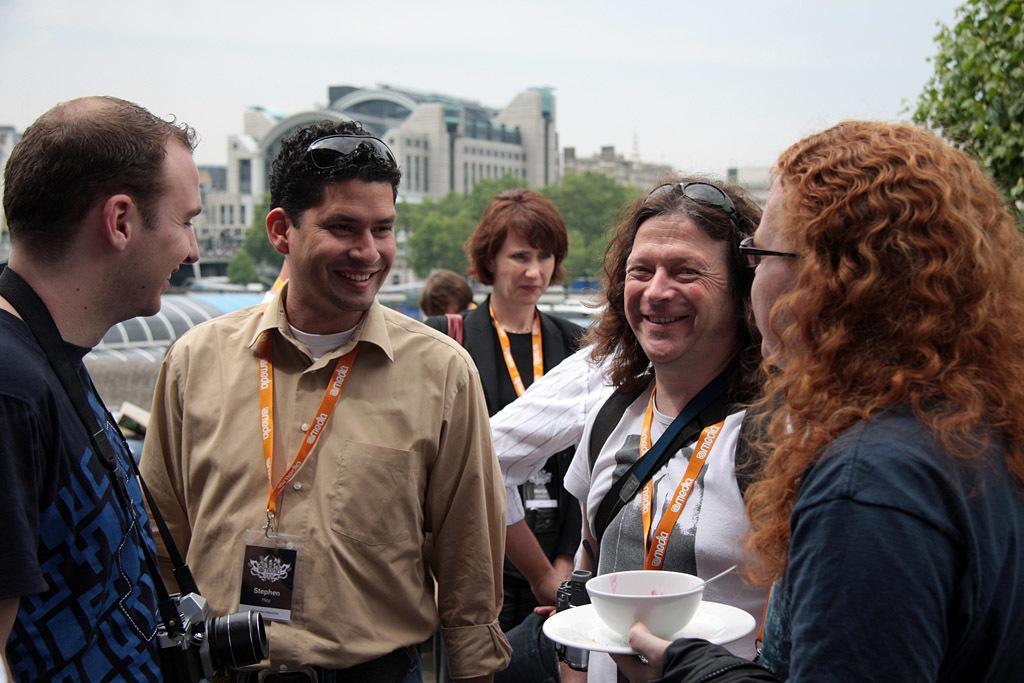Please provide a concise description of this image. In this picture there are people in the center of the image and there are buildings and trees in the background area of the image. 